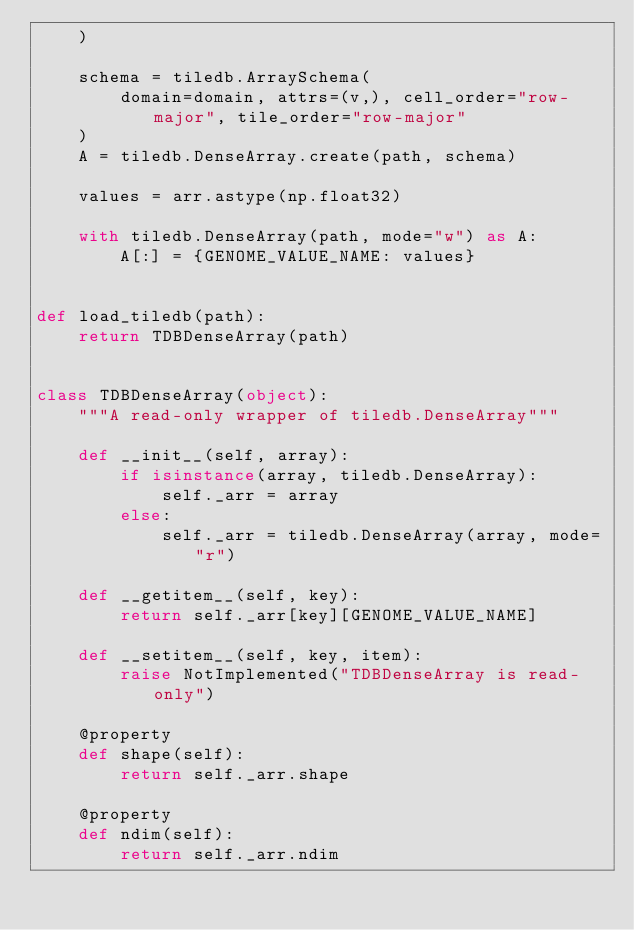Convert code to text. <code><loc_0><loc_0><loc_500><loc_500><_Python_>    )

    schema = tiledb.ArraySchema(
        domain=domain, attrs=(v,), cell_order="row-major", tile_order="row-major"
    )
    A = tiledb.DenseArray.create(path, schema)

    values = arr.astype(np.float32)

    with tiledb.DenseArray(path, mode="w") as A:
        A[:] = {GENOME_VALUE_NAME: values}


def load_tiledb(path):
    return TDBDenseArray(path)


class TDBDenseArray(object):
    """A read-only wrapper of tiledb.DenseArray"""

    def __init__(self, array):
        if isinstance(array, tiledb.DenseArray):
            self._arr = array
        else:
            self._arr = tiledb.DenseArray(array, mode="r")

    def __getitem__(self, key):
        return self._arr[key][GENOME_VALUE_NAME]

    def __setitem__(self, key, item):
        raise NotImplemented("TDBDenseArray is read-only")

    @property
    def shape(self):
        return self._arr.shape

    @property
    def ndim(self):
        return self._arr.ndim
</code> 